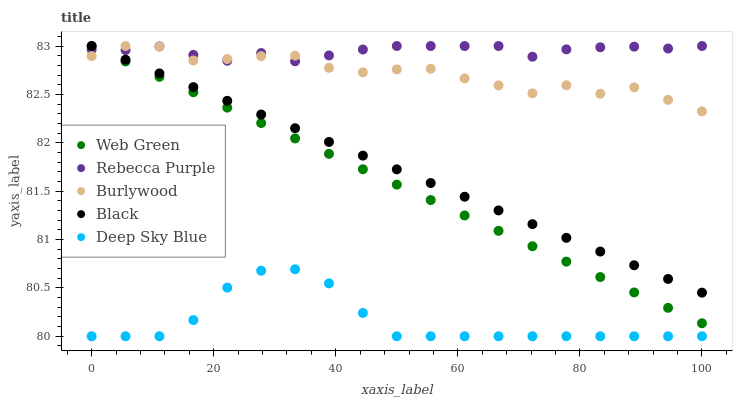Does Deep Sky Blue have the minimum area under the curve?
Answer yes or no. Yes. Does Rebecca Purple have the maximum area under the curve?
Answer yes or no. Yes. Does Black have the minimum area under the curve?
Answer yes or no. No. Does Black have the maximum area under the curve?
Answer yes or no. No. Is Black the smoothest?
Answer yes or no. Yes. Is Burlywood the roughest?
Answer yes or no. Yes. Is Deep Sky Blue the smoothest?
Answer yes or no. No. Is Deep Sky Blue the roughest?
Answer yes or no. No. Does Deep Sky Blue have the lowest value?
Answer yes or no. Yes. Does Black have the lowest value?
Answer yes or no. No. Does Web Green have the highest value?
Answer yes or no. Yes. Does Deep Sky Blue have the highest value?
Answer yes or no. No. Is Deep Sky Blue less than Web Green?
Answer yes or no. Yes. Is Rebecca Purple greater than Deep Sky Blue?
Answer yes or no. Yes. Does Web Green intersect Burlywood?
Answer yes or no. Yes. Is Web Green less than Burlywood?
Answer yes or no. No. Is Web Green greater than Burlywood?
Answer yes or no. No. Does Deep Sky Blue intersect Web Green?
Answer yes or no. No. 